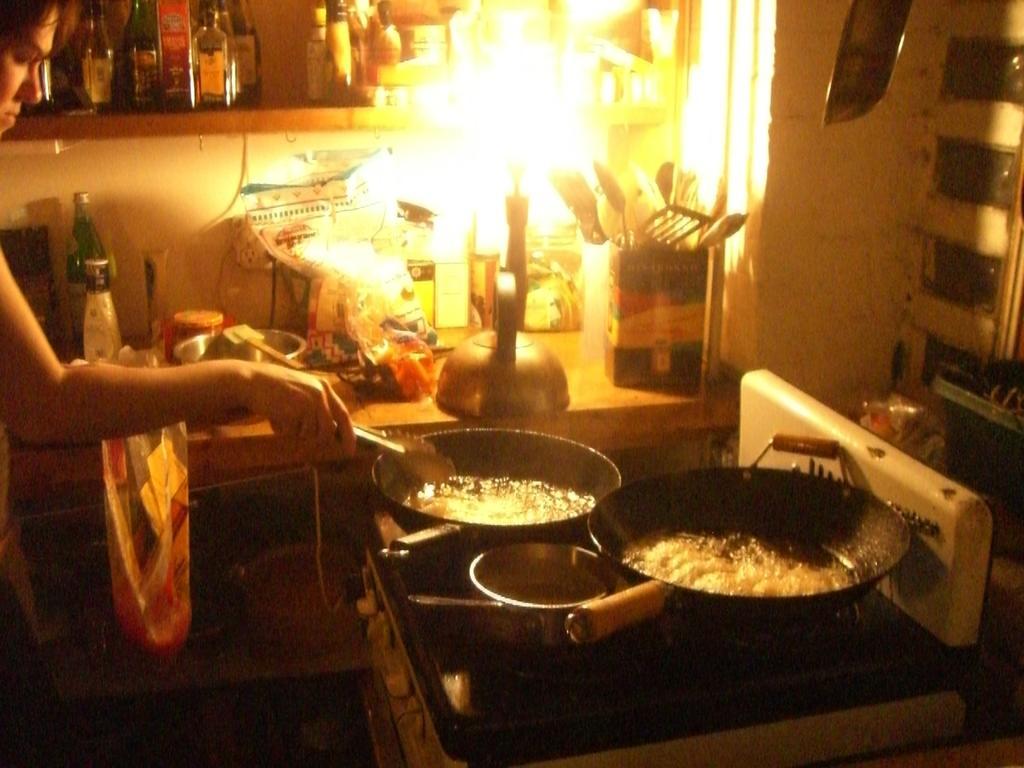Describe this image in one or two sentences. In this picture there is a woman standing and holding the tongs and there is food and oil in the pans. At the back there are bottles, utensils and covers on the table and there it looks like a candle on the table. 